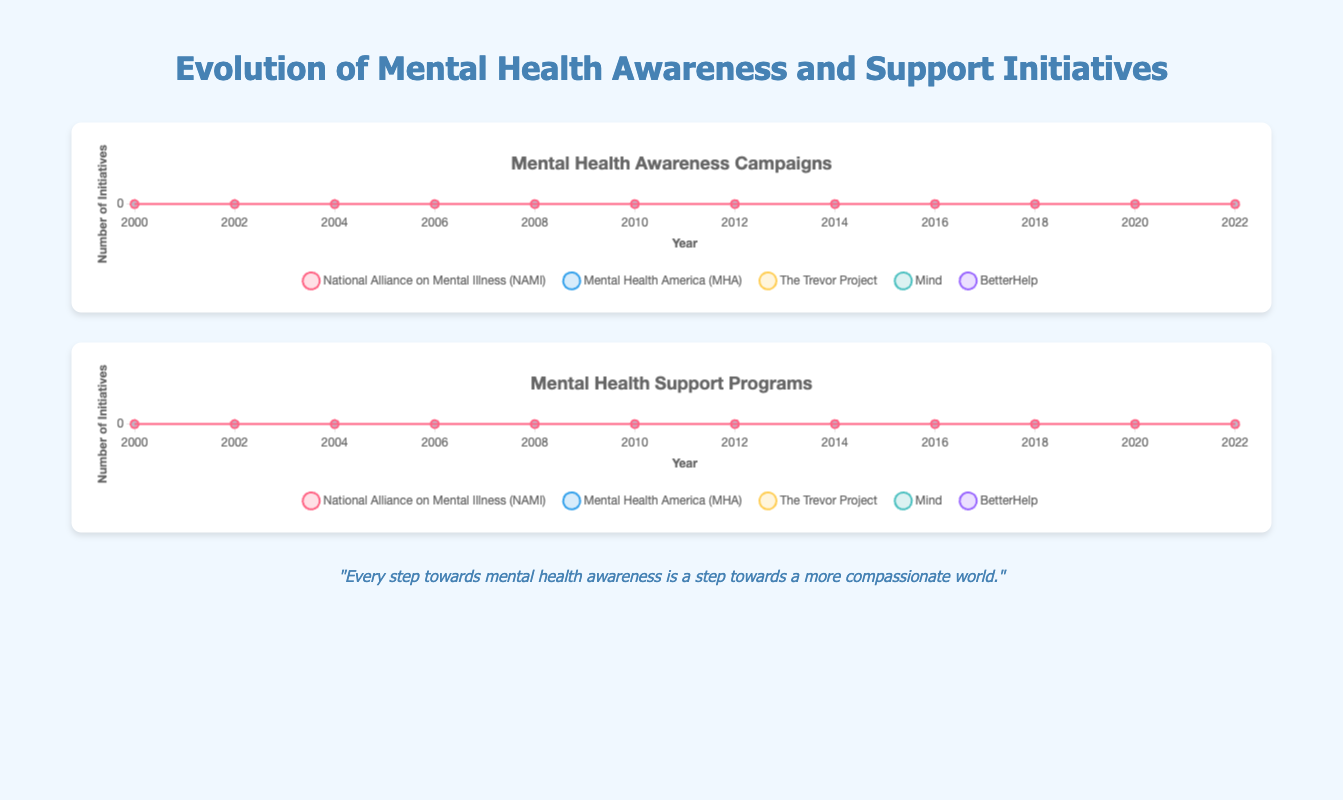What was the year that "BetterHelp" launched its first awareness campaign? According to the chart, "BetterHelp" first had an awareness campaign in the year 2006, marked by a data point starting in that year.
Answer: 2006 Between "NAMI" and "MHA", which organization had more support programs in 2010, and by how much? In 2010, "NAMI" had 6 support programs, while "MHA" had 5. The difference is 6 - 5 = 1 support program.
Answer: NAMI by 1 How many awareness campaigns did all the organizations combined have in 2018? Sum the awareness campaigns for each organization in 2018: NAMI (9) + MHA (8) + The Trevor Project (7) + Mind (8) + BetterHelp (9) = 41 campaigns.
Answer: 41 Which organization showed the greatest increase in support programs from 2016 to 2022? Calculate the increase for each organization: 
NAMI: 14 - 8 = 6, 
MHA: 11 - 7 = 4, 
The Trevor Project: 12 - 8 = 4, 
Mind: 10 - 7 = 3, 
BetterHelp: 12 - 7 = 5. 
NAMI shows the greatest increase.
Answer: NAMI Comparing awareness campaigns, which organization had the fastest growth rate from 2000 to 2022? Calculate the growth by dividing the final number by the initial number: 
For NAMI: 12/2 = 6, 
For MHA: 10/1 = 10, 
For The Trevor Project: 10/1 = 10, 
For Mind: 11/2 = 5.5, 
For BetterHelp: 12/0 is undefined but intuitively highest as it went from 0 to 12. 
MHA, The Trevor Project, and BetterHelp grew the fastest similarly, but BetterHelp's absolute increase seems more significant from 0.
Answer: BetterHelp By how much did "The Trevor Project" increase its number of awareness campaigns from 2008 to 2012? From 2008's data point of 3 to 2012's data point of 5, the increase is 5 - 3 = 2 campaigns.
Answer: 2 Which organization had the lowest number of support programs in 2000 and how many? In 2000, "Mind" had the lowest number of support programs, with 1 program.
Answer: Mind with 1 Did any of the organizations maintain the same number of awareness campaigns between consecutive years? If yes, name one such instance. Yes, "NAMI" maintained the same number of awareness campaigns (5) between 2004 and 2006.
Answer: Yes, NAMI between 2004 and 2006 